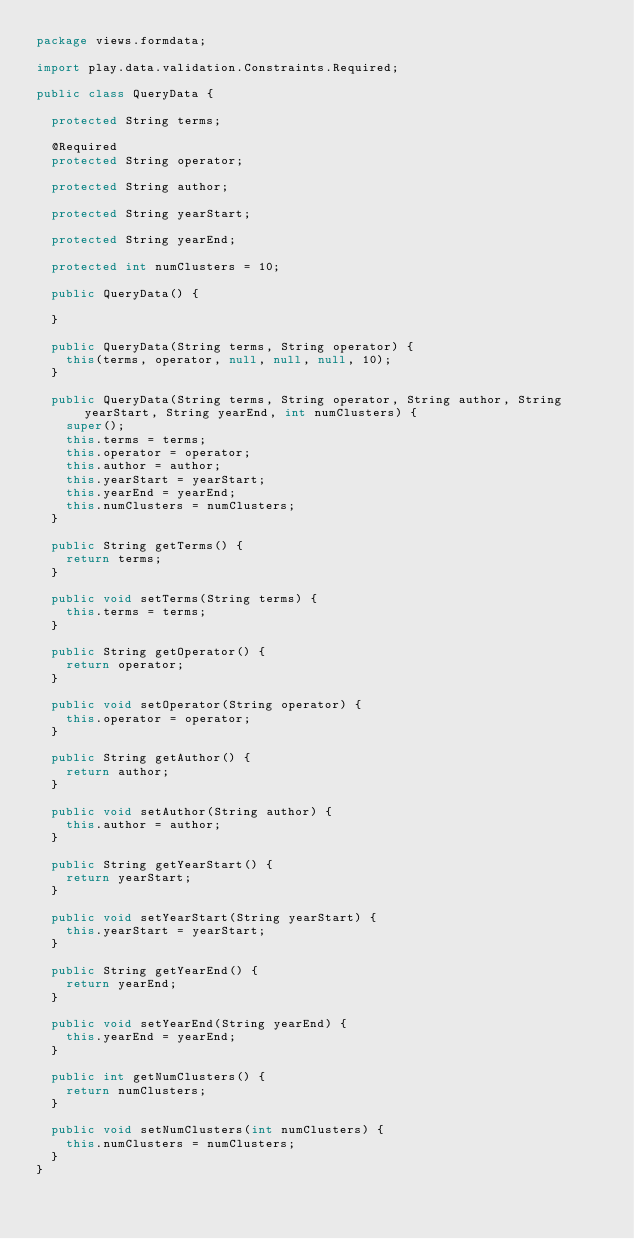<code> <loc_0><loc_0><loc_500><loc_500><_Java_>package views.formdata;

import play.data.validation.Constraints.Required;

public class QueryData {
	
	protected String terms;
	
	@Required
	protected String operator;
	
	protected String author;
	
	protected String yearStart;
	
	protected String yearEnd;
	
	protected int numClusters = 10;
	
	public QueryData() {
		
	}
	
	public QueryData(String terms, String operator) {
		this(terms, operator, null, null, null, 10);
	}

	public QueryData(String terms, String operator, String author, String yearStart, String yearEnd, int numClusters) {
		super();
		this.terms = terms;
		this.operator = operator;
		this.author = author;
		this.yearStart = yearStart;
		this.yearEnd = yearEnd;
		this.numClusters = numClusters;
	}

	public String getTerms() {
		return terms;
	}

	public void setTerms(String terms) {
		this.terms = terms;
	}

	public String getOperator() {
		return operator;
	}

	public void setOperator(String operator) {
		this.operator = operator;
	}

	public String getAuthor() {
		return author;
	}

	public void setAuthor(String author) {
		this.author = author;
	}

	public String getYearStart() {
		return yearStart;
	}

	public void setYearStart(String yearStart) {
		this.yearStart = yearStart;
	}

	public String getYearEnd() {
		return yearEnd;
	}

	public void setYearEnd(String yearEnd) {
		this.yearEnd = yearEnd;
	}

	public int getNumClusters() {
		return numClusters;
	}
	
	public void setNumClusters(int numClusters) {
		this.numClusters = numClusters;
	}
}
</code> 